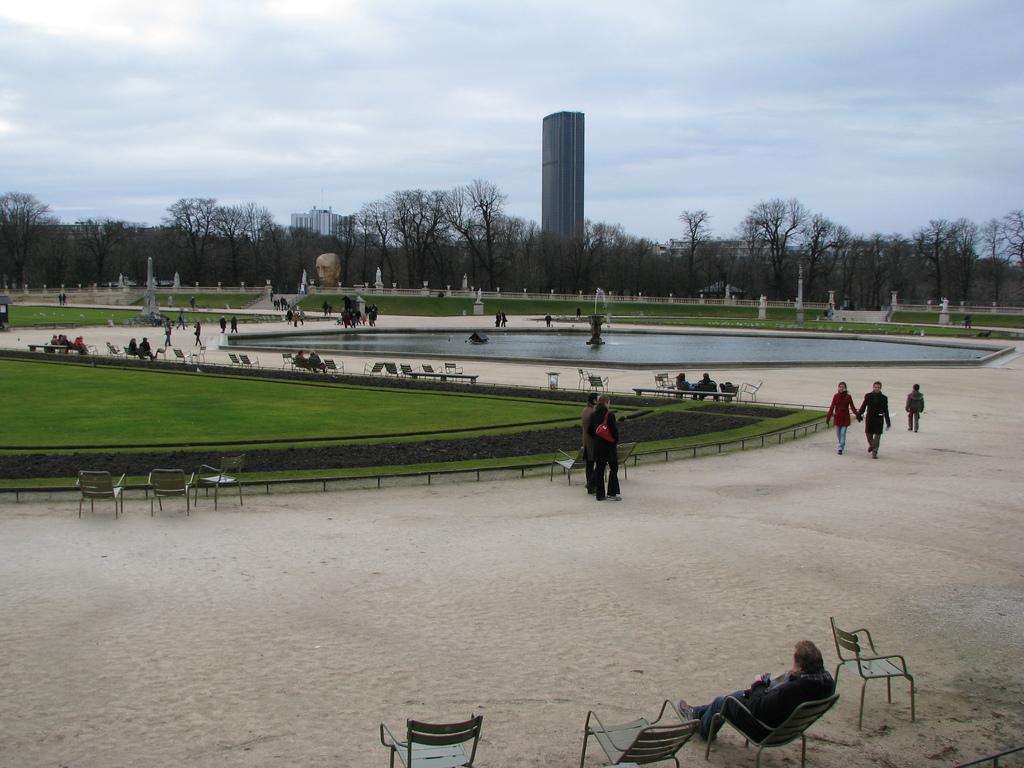Describe this image in one or two sentences. In this image we can see few people, some of them are walking on the road and some of them are sitting on the chairs, there is a fountain, water, grass, few trees, buildings and the sky in the background. 